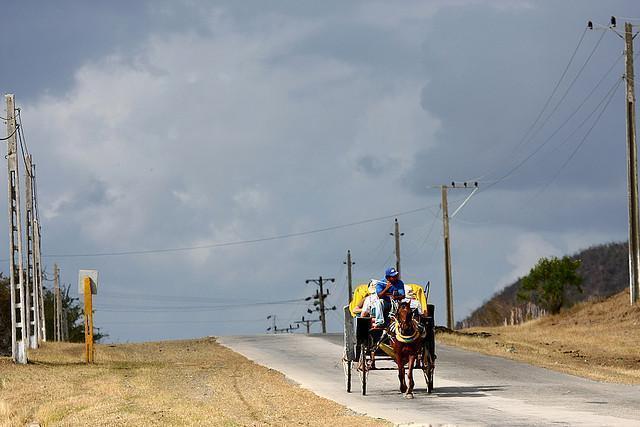What is the tallest item here?
Pick the right solution, then justify: 'Answer: answer
Rationale: rationale.'
Options: Horse, building, bush, telephone pole. Answer: telephone pole.
Rationale: There are tall phone lines. 